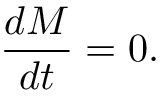<formula> <loc_0><loc_0><loc_500><loc_500>\frac { d M } { d t } = 0 .</formula> 